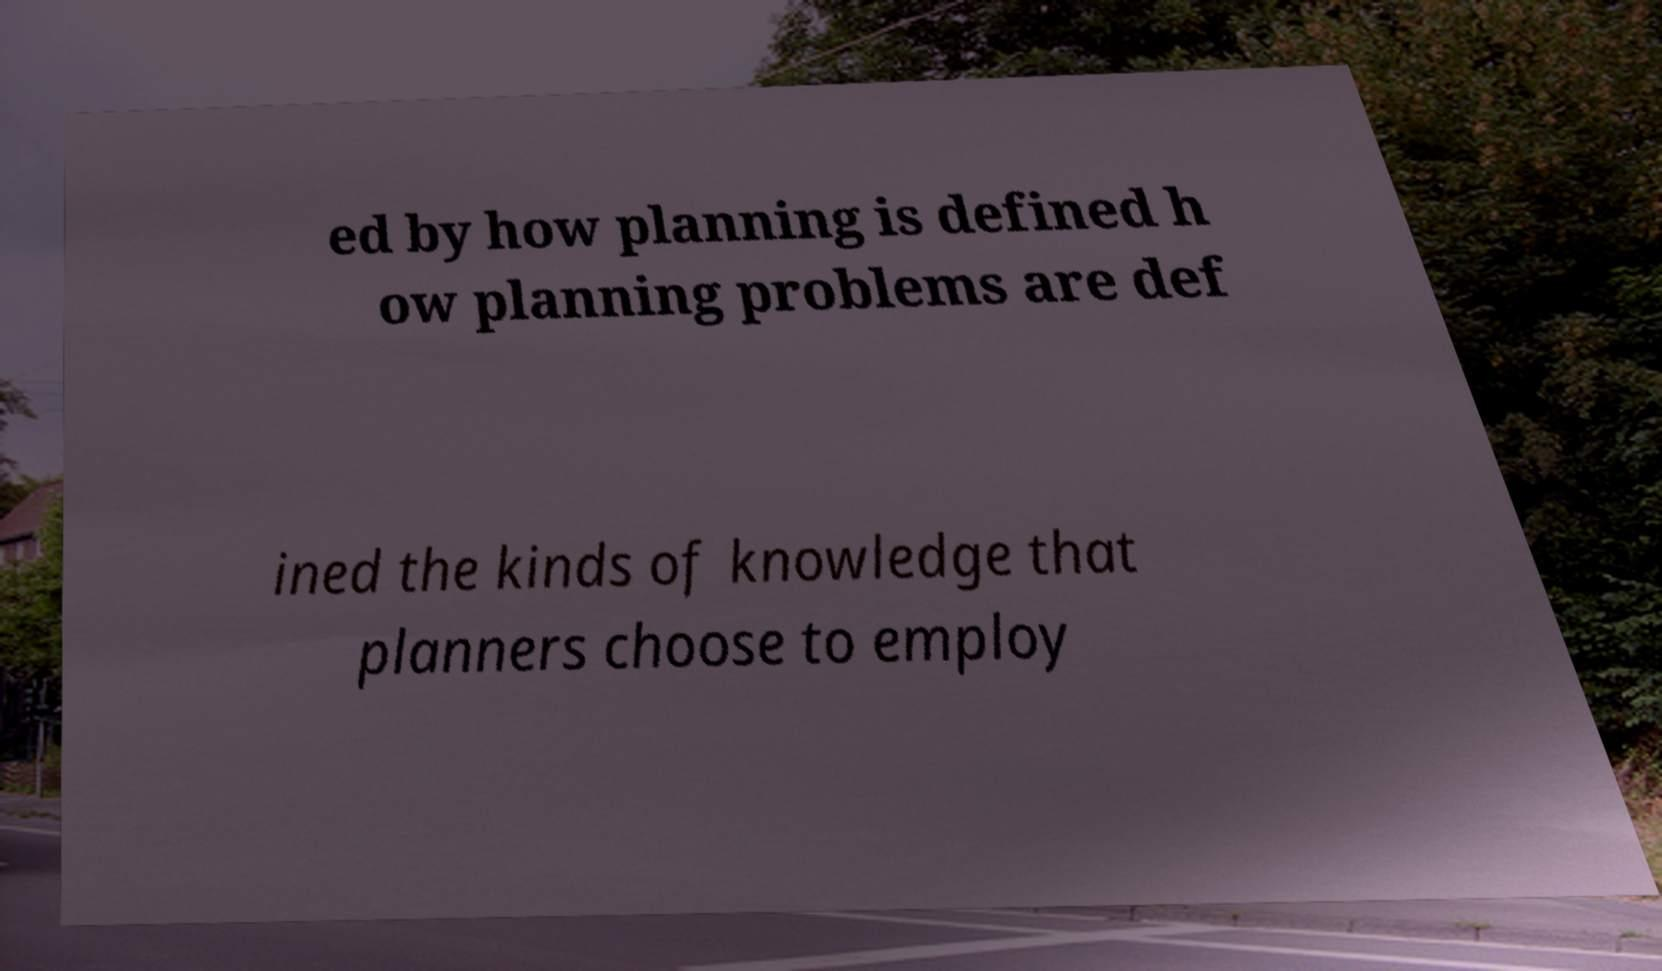I need the written content from this picture converted into text. Can you do that? ed by how planning is defined h ow planning problems are def ined the kinds of knowledge that planners choose to employ 